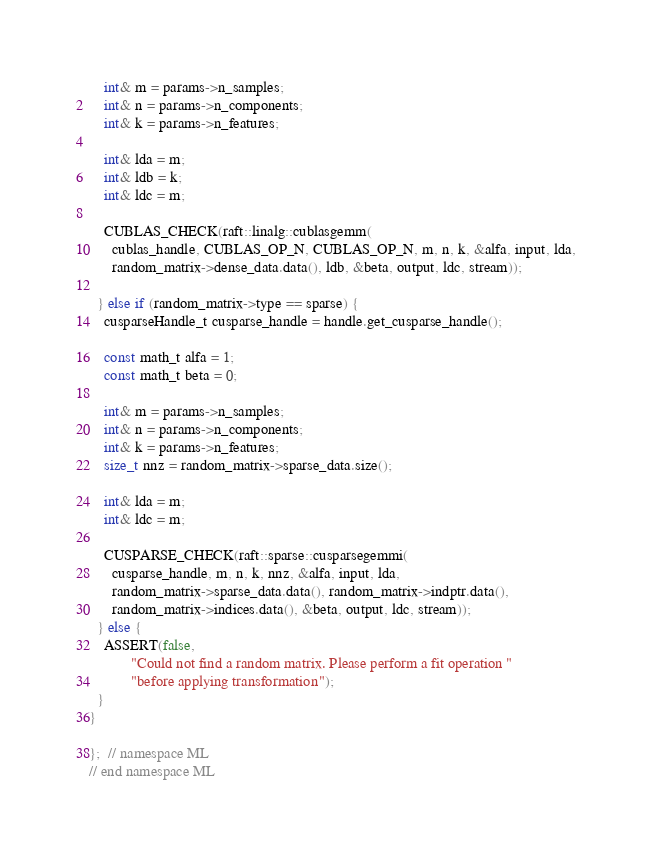Convert code to text. <code><loc_0><loc_0><loc_500><loc_500><_Cuda_>
    int& m = params->n_samples;
    int& n = params->n_components;
    int& k = params->n_features;

    int& lda = m;
    int& ldb = k;
    int& ldc = m;

    CUBLAS_CHECK(raft::linalg::cublasgemm(
      cublas_handle, CUBLAS_OP_N, CUBLAS_OP_N, m, n, k, &alfa, input, lda,
      random_matrix->dense_data.data(), ldb, &beta, output, ldc, stream));

  } else if (random_matrix->type == sparse) {
    cusparseHandle_t cusparse_handle = handle.get_cusparse_handle();

    const math_t alfa = 1;
    const math_t beta = 0;

    int& m = params->n_samples;
    int& n = params->n_components;
    int& k = params->n_features;
    size_t nnz = random_matrix->sparse_data.size();

    int& lda = m;
    int& ldc = m;

    CUSPARSE_CHECK(raft::sparse::cusparsegemmi(
      cusparse_handle, m, n, k, nnz, &alfa, input, lda,
      random_matrix->sparse_data.data(), random_matrix->indptr.data(),
      random_matrix->indices.data(), &beta, output, ldc, stream));
  } else {
    ASSERT(false,
           "Could not find a random matrix. Please perform a fit operation "
           "before applying transformation");
  }
}

};  // namespace ML
// end namespace ML
</code> 